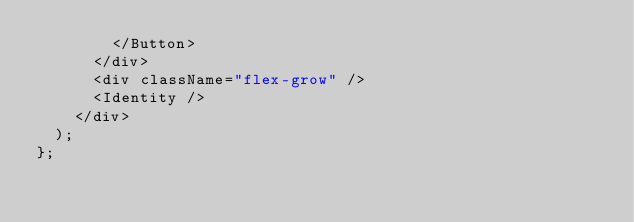Convert code to text. <code><loc_0><loc_0><loc_500><loc_500><_TypeScript_>        </Button>
      </div>
      <div className="flex-grow" />
      <Identity />
    </div>
  );
};
</code> 